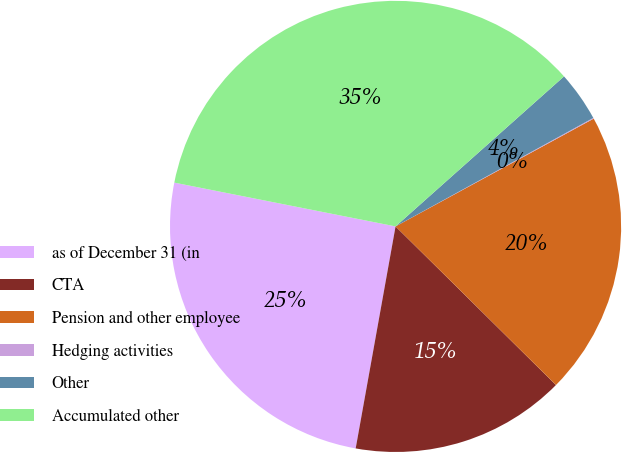Convert chart. <chart><loc_0><loc_0><loc_500><loc_500><pie_chart><fcel>as of December 31 (in<fcel>CTA<fcel>Pension and other employee<fcel>Hedging activities<fcel>Other<fcel>Accumulated other<nl><fcel>25.28%<fcel>15.42%<fcel>20.34%<fcel>0.06%<fcel>3.59%<fcel>35.31%<nl></chart> 